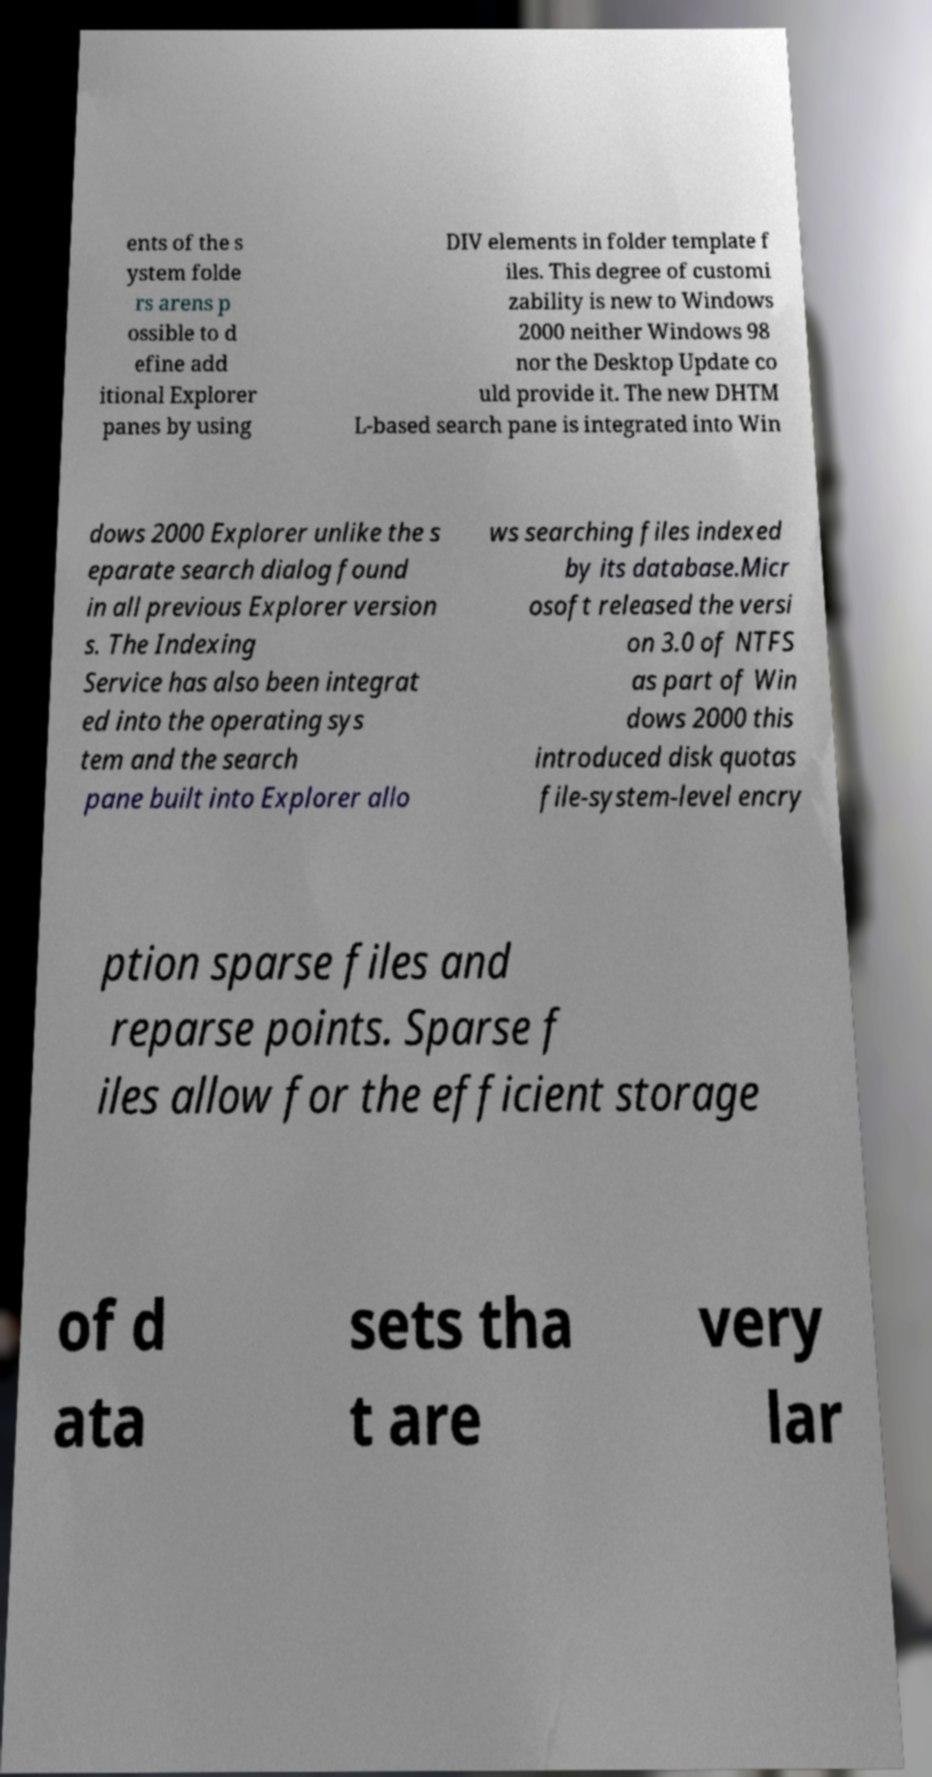I need the written content from this picture converted into text. Can you do that? ents of the s ystem folde rs arens p ossible to d efine add itional Explorer panes by using DIV elements in folder template f iles. This degree of customi zability is new to Windows 2000 neither Windows 98 nor the Desktop Update co uld provide it. The new DHTM L-based search pane is integrated into Win dows 2000 Explorer unlike the s eparate search dialog found in all previous Explorer version s. The Indexing Service has also been integrat ed into the operating sys tem and the search pane built into Explorer allo ws searching files indexed by its database.Micr osoft released the versi on 3.0 of NTFS as part of Win dows 2000 this introduced disk quotas file-system-level encry ption sparse files and reparse points. Sparse f iles allow for the efficient storage of d ata sets tha t are very lar 